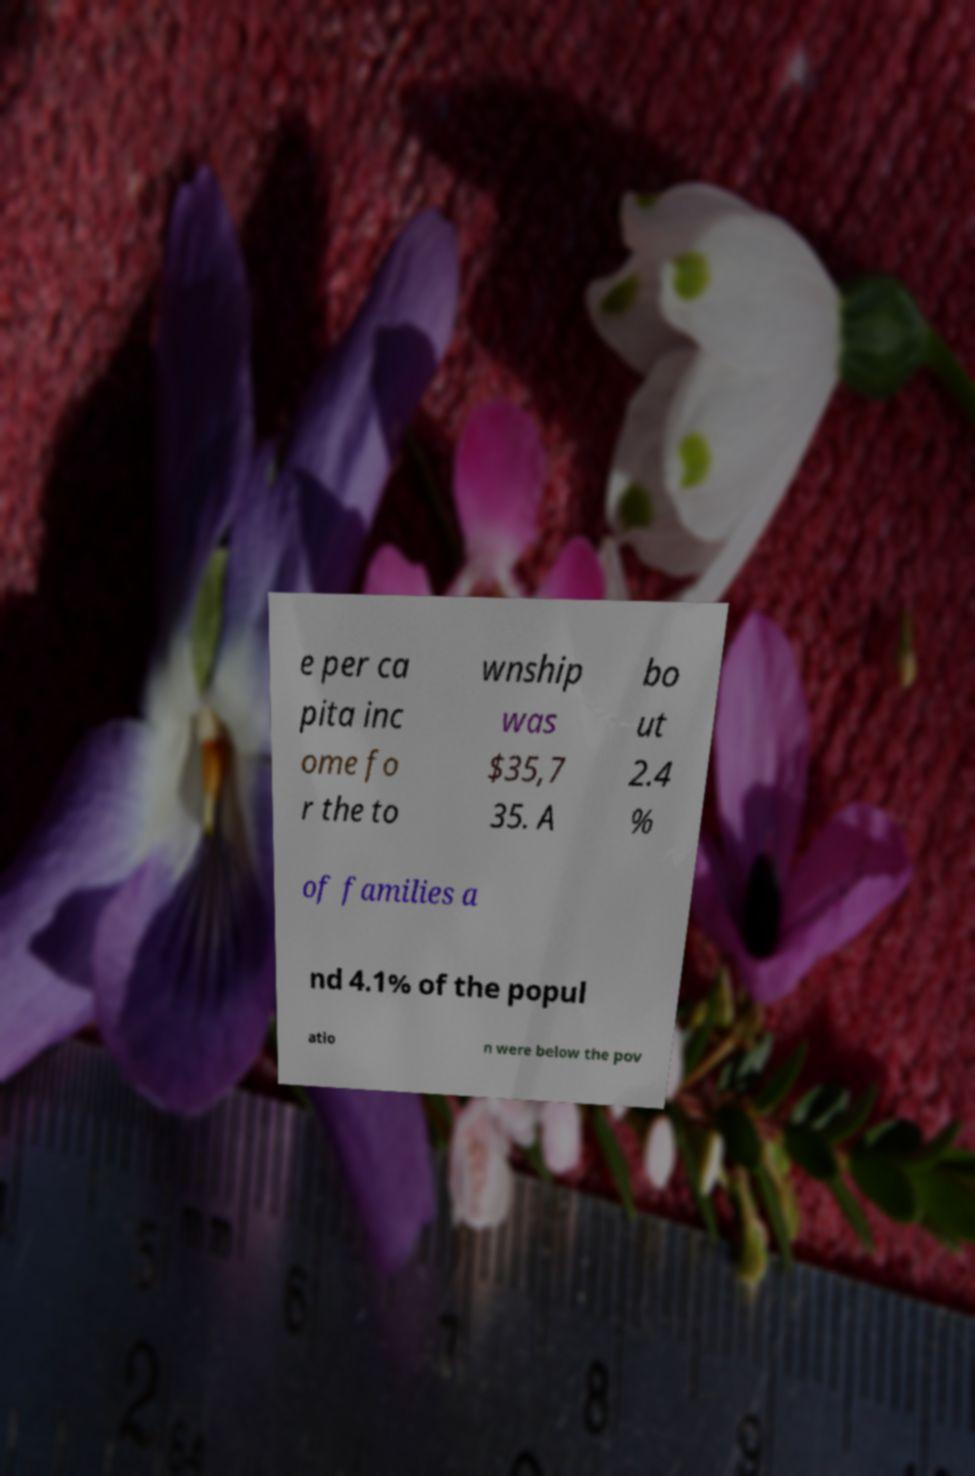Please identify and transcribe the text found in this image. e per ca pita inc ome fo r the to wnship was $35,7 35. A bo ut 2.4 % of families a nd 4.1% of the popul atio n were below the pov 